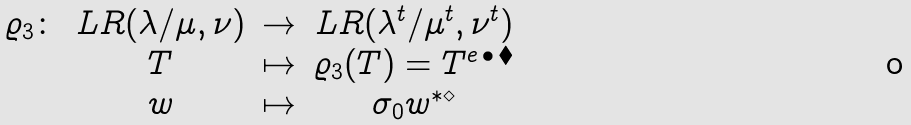<formula> <loc_0><loc_0><loc_500><loc_500>\begin{matrix} \varrho _ { 3 } \colon & L R ( \lambda / \mu , \nu ) & \rightarrow & L R ( \lambda ^ { t } / \mu ^ { t } , \nu ^ { t } ) \\ & T & \mapsto & \varrho _ { 3 } ( T ) = T ^ { e \, \bullet \, \blacklozenge } \\ & w & \mapsto & \sigma _ { 0 } w ^ { * \diamond } \end{matrix}</formula> 